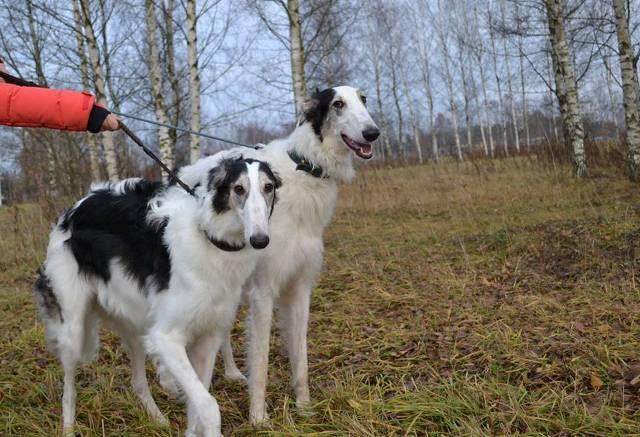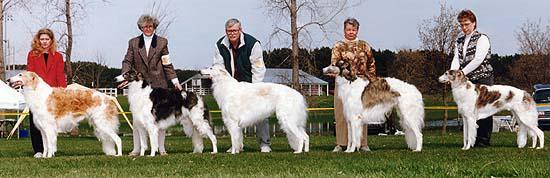The first image is the image on the left, the second image is the image on the right. For the images displayed, is the sentence "There are no more than two dogs in the right image standing on green grass." factually correct? Answer yes or no. No. The first image is the image on the left, the second image is the image on the right. Considering the images on both sides, is "At least three people, including one in bright red, stand in a row behind dogs standing on grass." valid? Answer yes or no. Yes. 